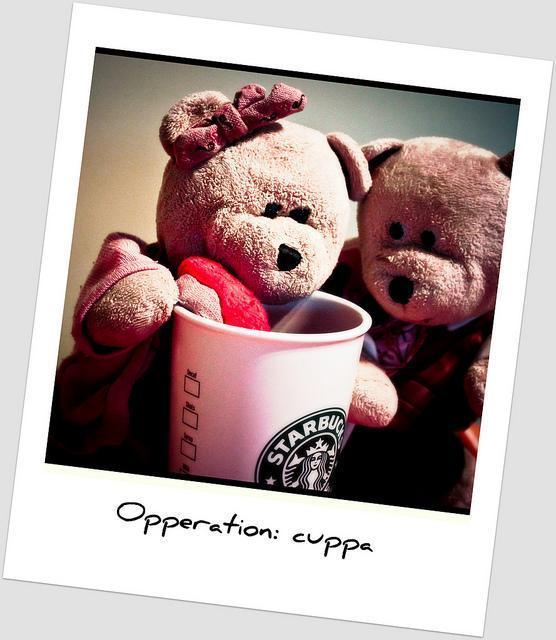How many teddy bears are there?
Give a very brief answer. 2. How many dogs are in the picture?
Give a very brief answer. 0. 